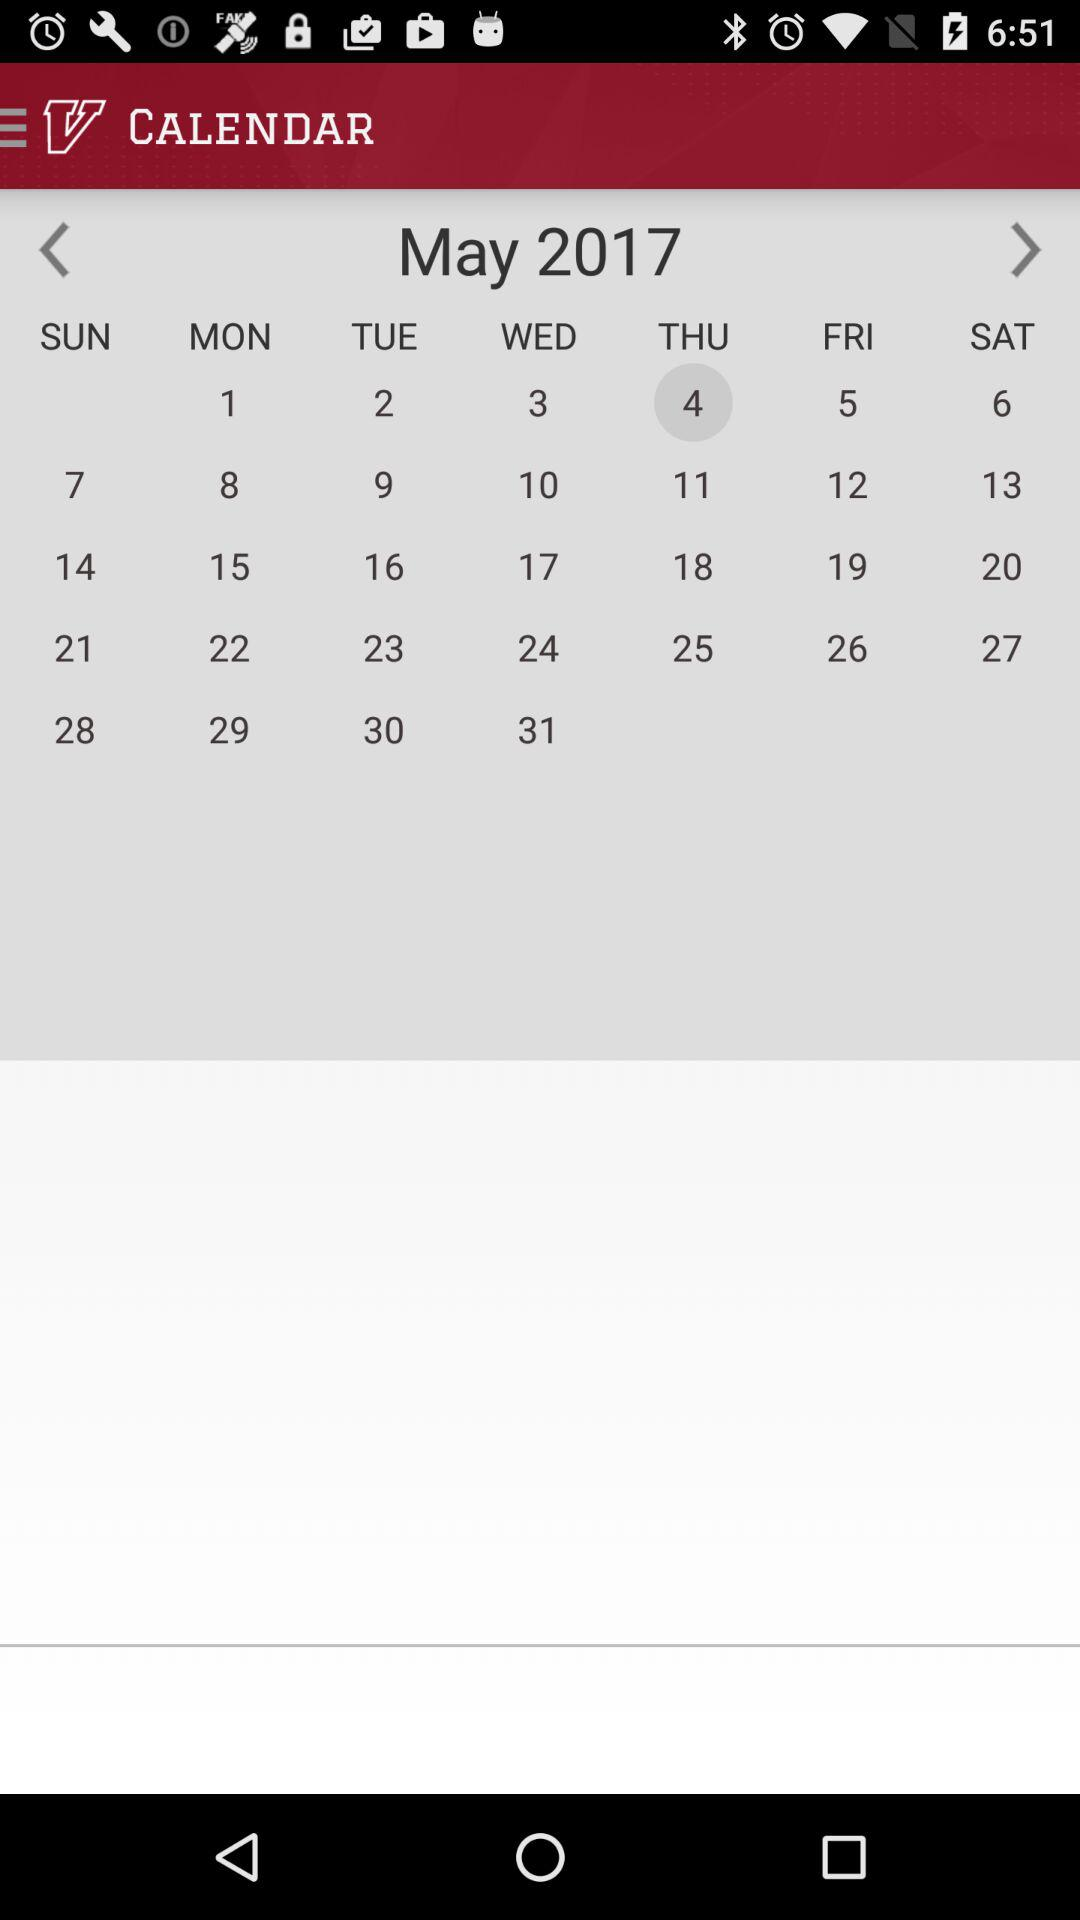What will the day be on May 4th? The day that will be on May 4th is Thursday. 